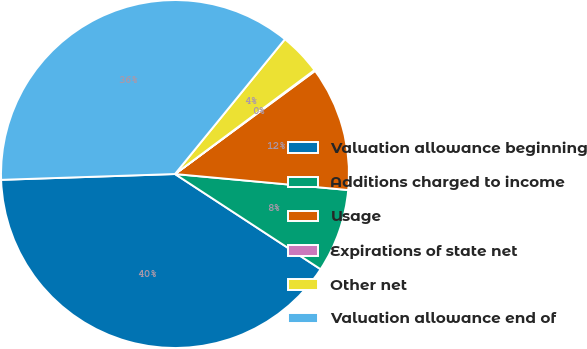Convert chart to OTSL. <chart><loc_0><loc_0><loc_500><loc_500><pie_chart><fcel>Valuation allowance beginning<fcel>Additions charged to income<fcel>Usage<fcel>Expirations of state net<fcel>Other net<fcel>Valuation allowance end of<nl><fcel>40.25%<fcel>7.75%<fcel>11.57%<fcel>0.09%<fcel>3.92%<fcel>36.42%<nl></chart> 